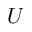<formula> <loc_0><loc_0><loc_500><loc_500>U</formula> 